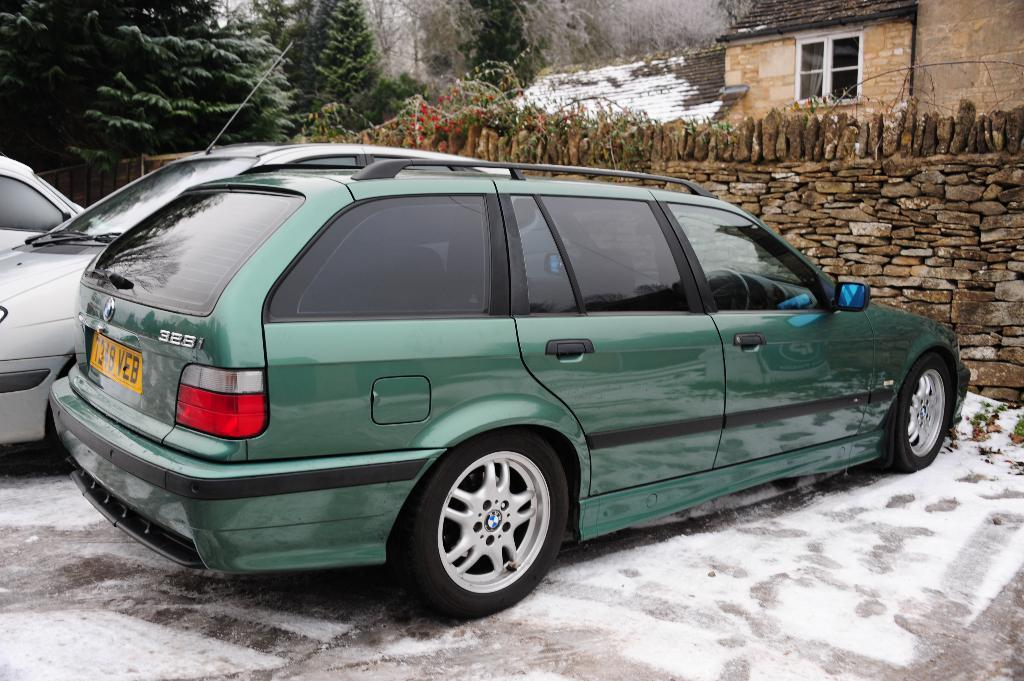What type of vehicles can be seen in the image? There are cars in the image. What is covering the ground in the image? There is snow at the bottom of the image. What can be seen in the background of the image? There is a house and trees in the background of the image. What is the middle of the image characterized by? There is a stone wall in the middle of the image. Can you see any connection between the cars and the ocean in the image? There is no ocean present in the image, so it is not possible to see any connection between the cars and the ocean. 